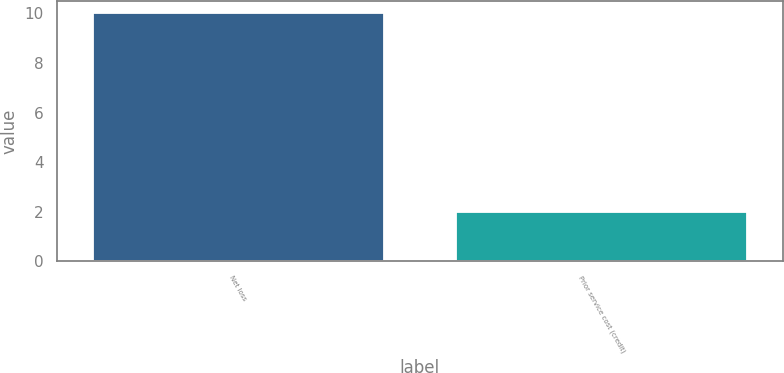<chart> <loc_0><loc_0><loc_500><loc_500><bar_chart><fcel>Net loss<fcel>Prior service cost (credit)<nl><fcel>10<fcel>2<nl></chart> 